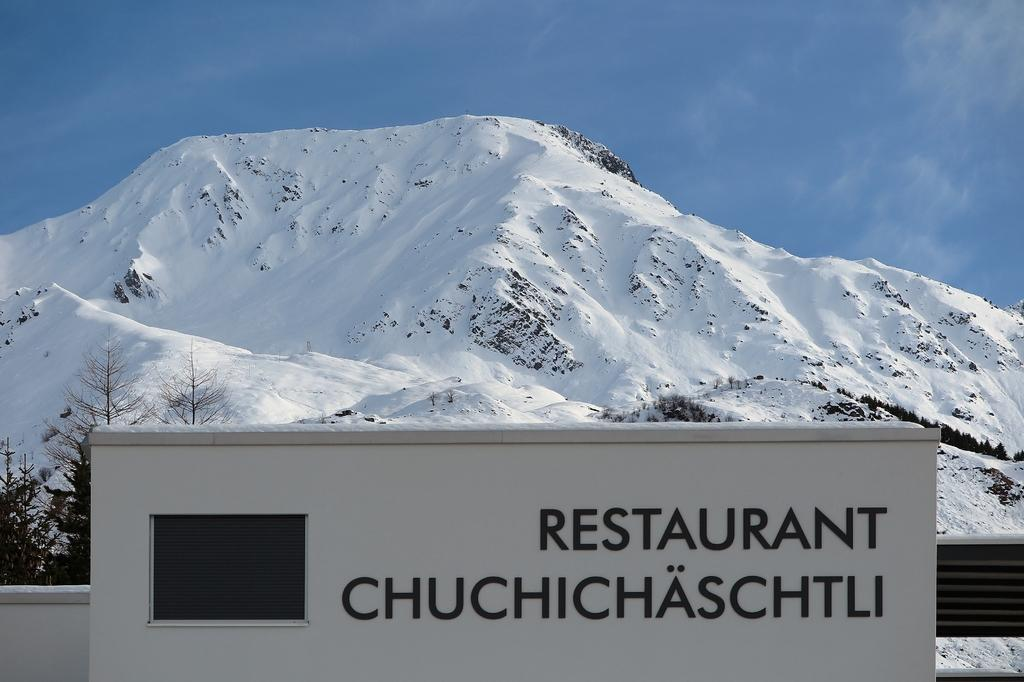Provide a one-sentence caption for the provided image. Infront of a snow covered mountain is a sign for a restaurant. 